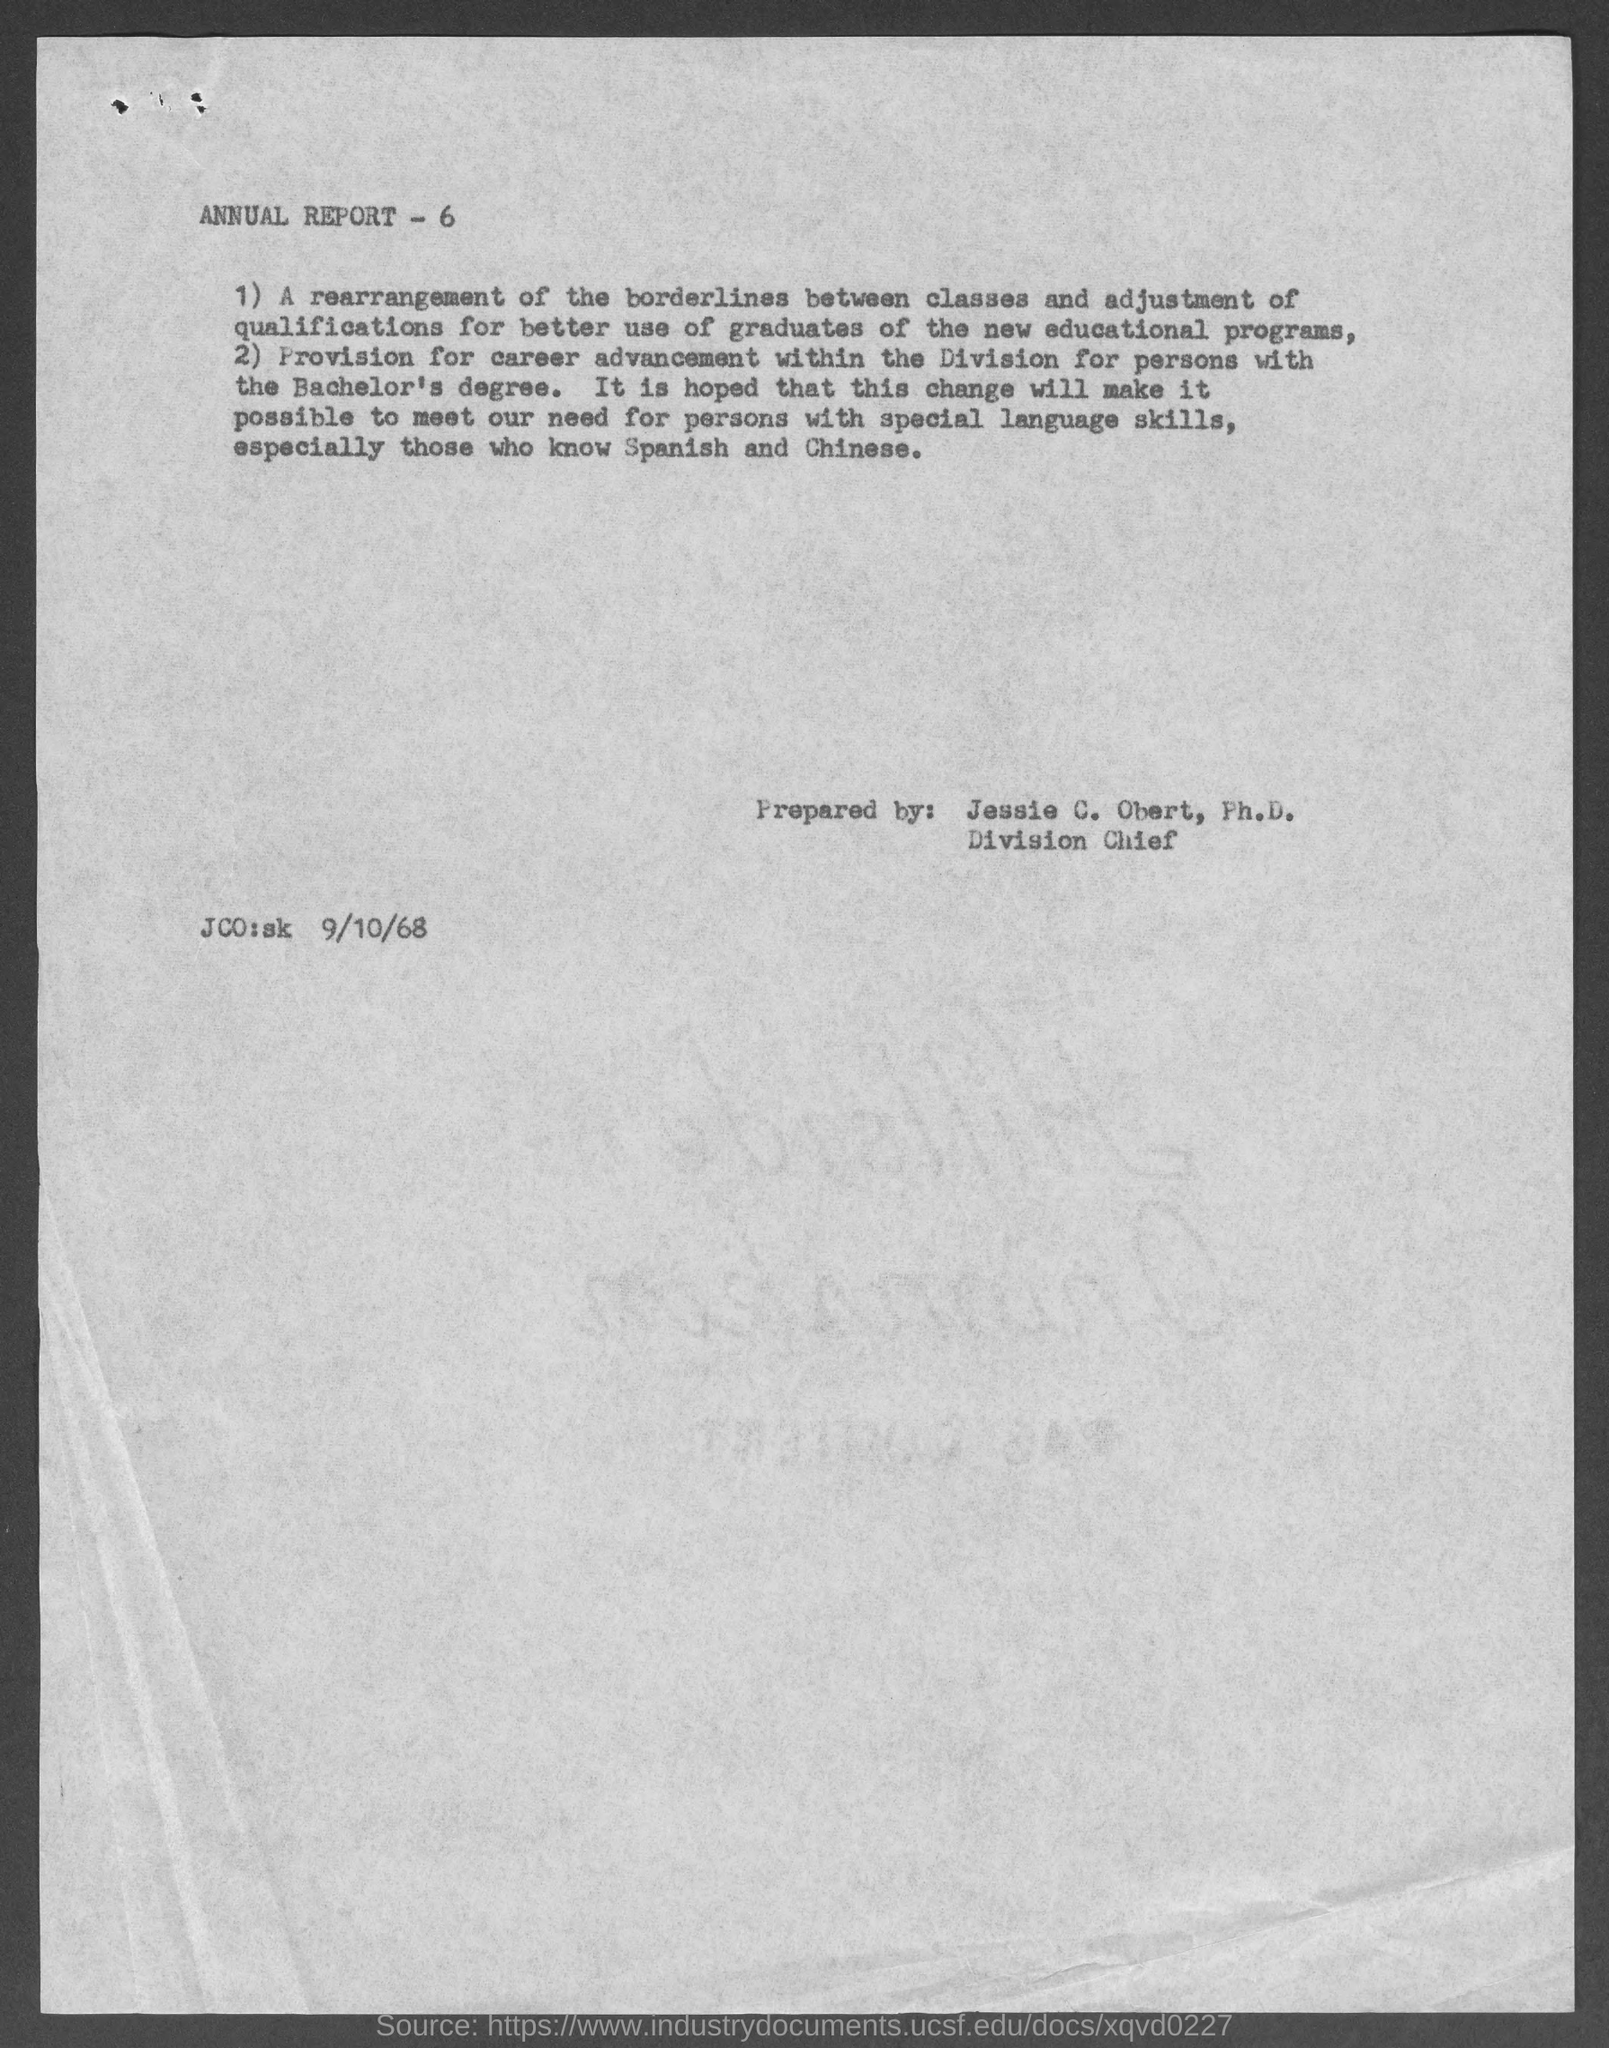List a handful of essential elements in this visual. The person named Jessie C. Obert prepared an annual report for the year 2020. Jessie C. Obert, Ph.D., is the Division Chief. 